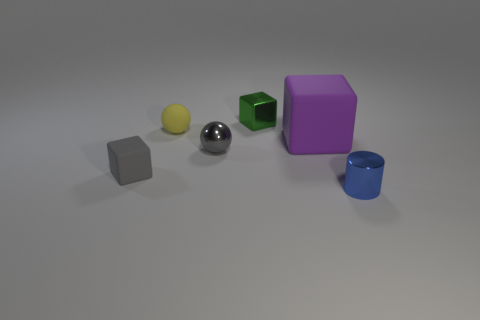Subtract all rubber cubes. How many cubes are left? 1 Add 1 tiny gray blocks. How many objects exist? 7 Subtract all blue cubes. Subtract all cyan cylinders. How many cubes are left? 3 Subtract all cylinders. How many objects are left? 5 Subtract 0 brown cylinders. How many objects are left? 6 Subtract all yellow rubber things. Subtract all rubber spheres. How many objects are left? 4 Add 6 purple rubber blocks. How many purple rubber blocks are left? 7 Add 5 yellow things. How many yellow things exist? 6 